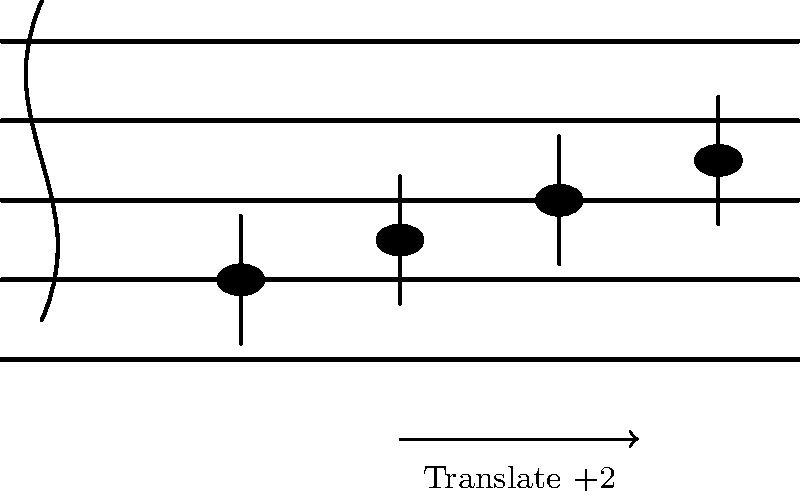In the staff diagram above, a simple C major chord progression is shown. If we translate each note up by two positions on the staff (equivalent to a whole step in music theory), what new chord progression would be formed? To solve this problem, we need to follow these steps:

1. Identify the original notes:
   - The first note is on the bottom line, which is C in treble clef.
   - The second note is on the first space, which is D.
   - The third note is on the second line, which is E.
   - The fourth note is in the second space, which is F.

2. Translate each note up by two positions:
   - C moves up two positions to E.
   - D moves up two positions to F.
   - E moves up two positions to G.
   - F moves up two positions to A.

3. Identify the new chord progression:
   The new notes are E, F, G, and A.

4. Analyze the new chord progression:
   - E is the root note.
   - G is the third (major third from E).
   - B would be the fifth, but it's not present.

Therefore, the new chord progression is based on an E minor chord (Em), with an added fourth (A). This could be interpreted as an Em7 chord with the seventh (D) replaced by the fourth (A), or as an Esus4 chord with an added minor third.
Answer: Em(add4) or Esus4(add$\flat$3) 